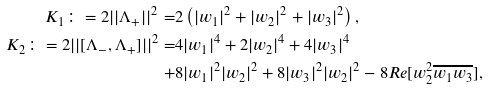Convert formula to latex. <formula><loc_0><loc_0><loc_500><loc_500>K _ { 1 } \colon = 2 | | \Lambda _ { + } | | ^ { 2 } = & 2 \left ( | w _ { 1 } | ^ { 2 } + | w _ { 2 } | ^ { 2 } + | w _ { 3 } | ^ { 2 } \right ) , \\ K _ { 2 } \colon = 2 | | [ \Lambda _ { - } , \Lambda _ { + } ] | | ^ { 2 } = & 4 | w _ { 1 } | ^ { 4 } + 2 | w _ { 2 } | ^ { 4 } + 4 | w _ { 3 } | ^ { 4 } \\ + & 8 | w _ { 1 } | ^ { 2 } | w _ { 2 } | ^ { 2 } + 8 | w _ { 3 } | ^ { 2 } | w _ { 2 } | ^ { 2 } - 8 R e [ w _ { 2 } ^ { 2 } \overline { w _ { 1 } w _ { 3 } } ] ,</formula> 